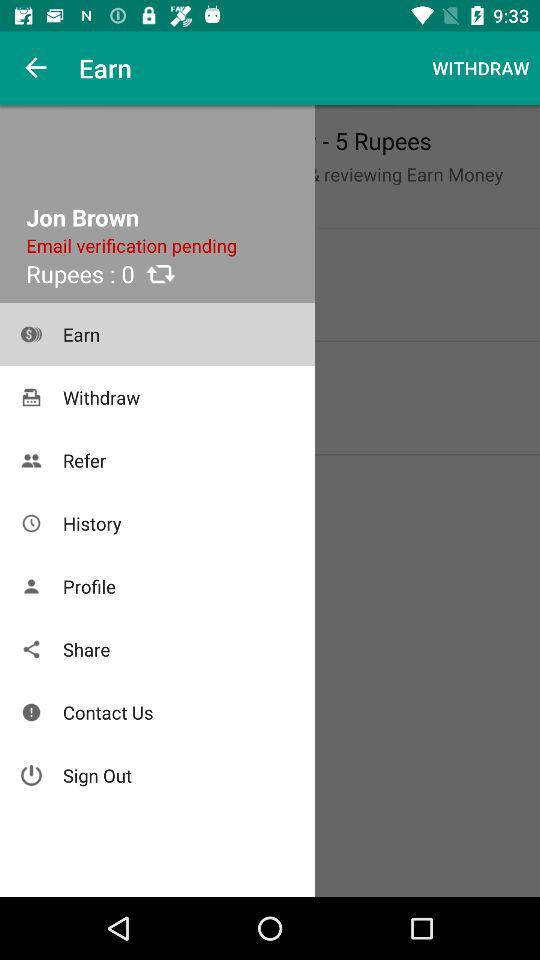Which option is selected? The selected option is "Earn". 